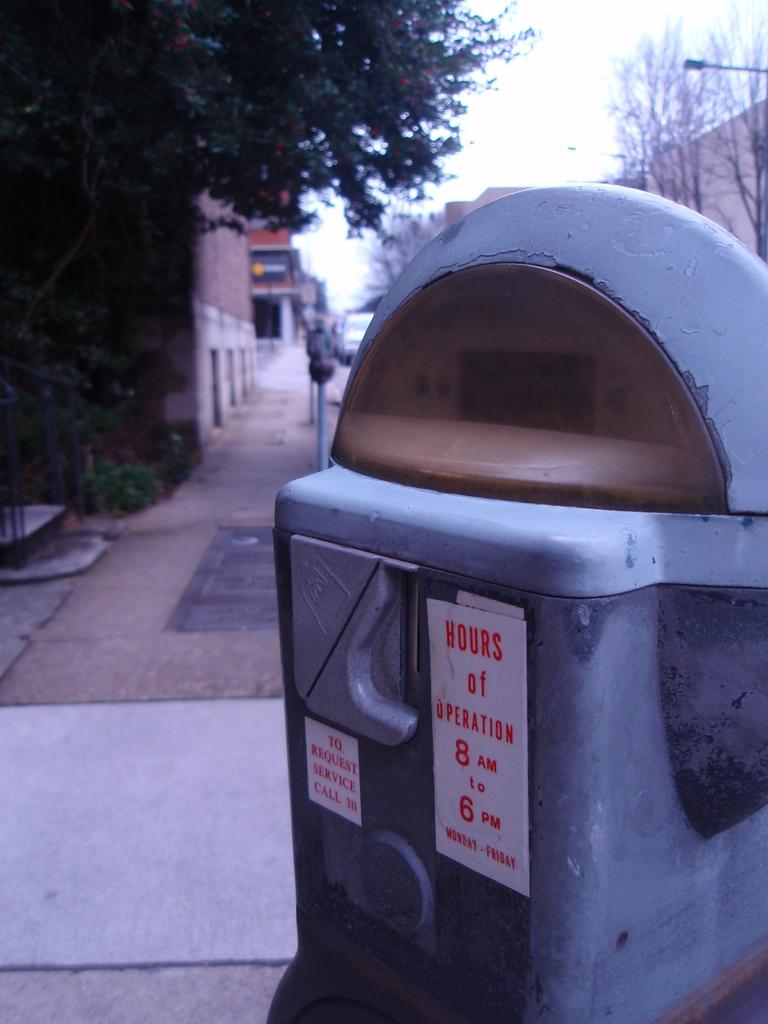<image>
Give a short and clear explanation of the subsequent image. a parking meter that has a sign that says 'hours of operation' on it 